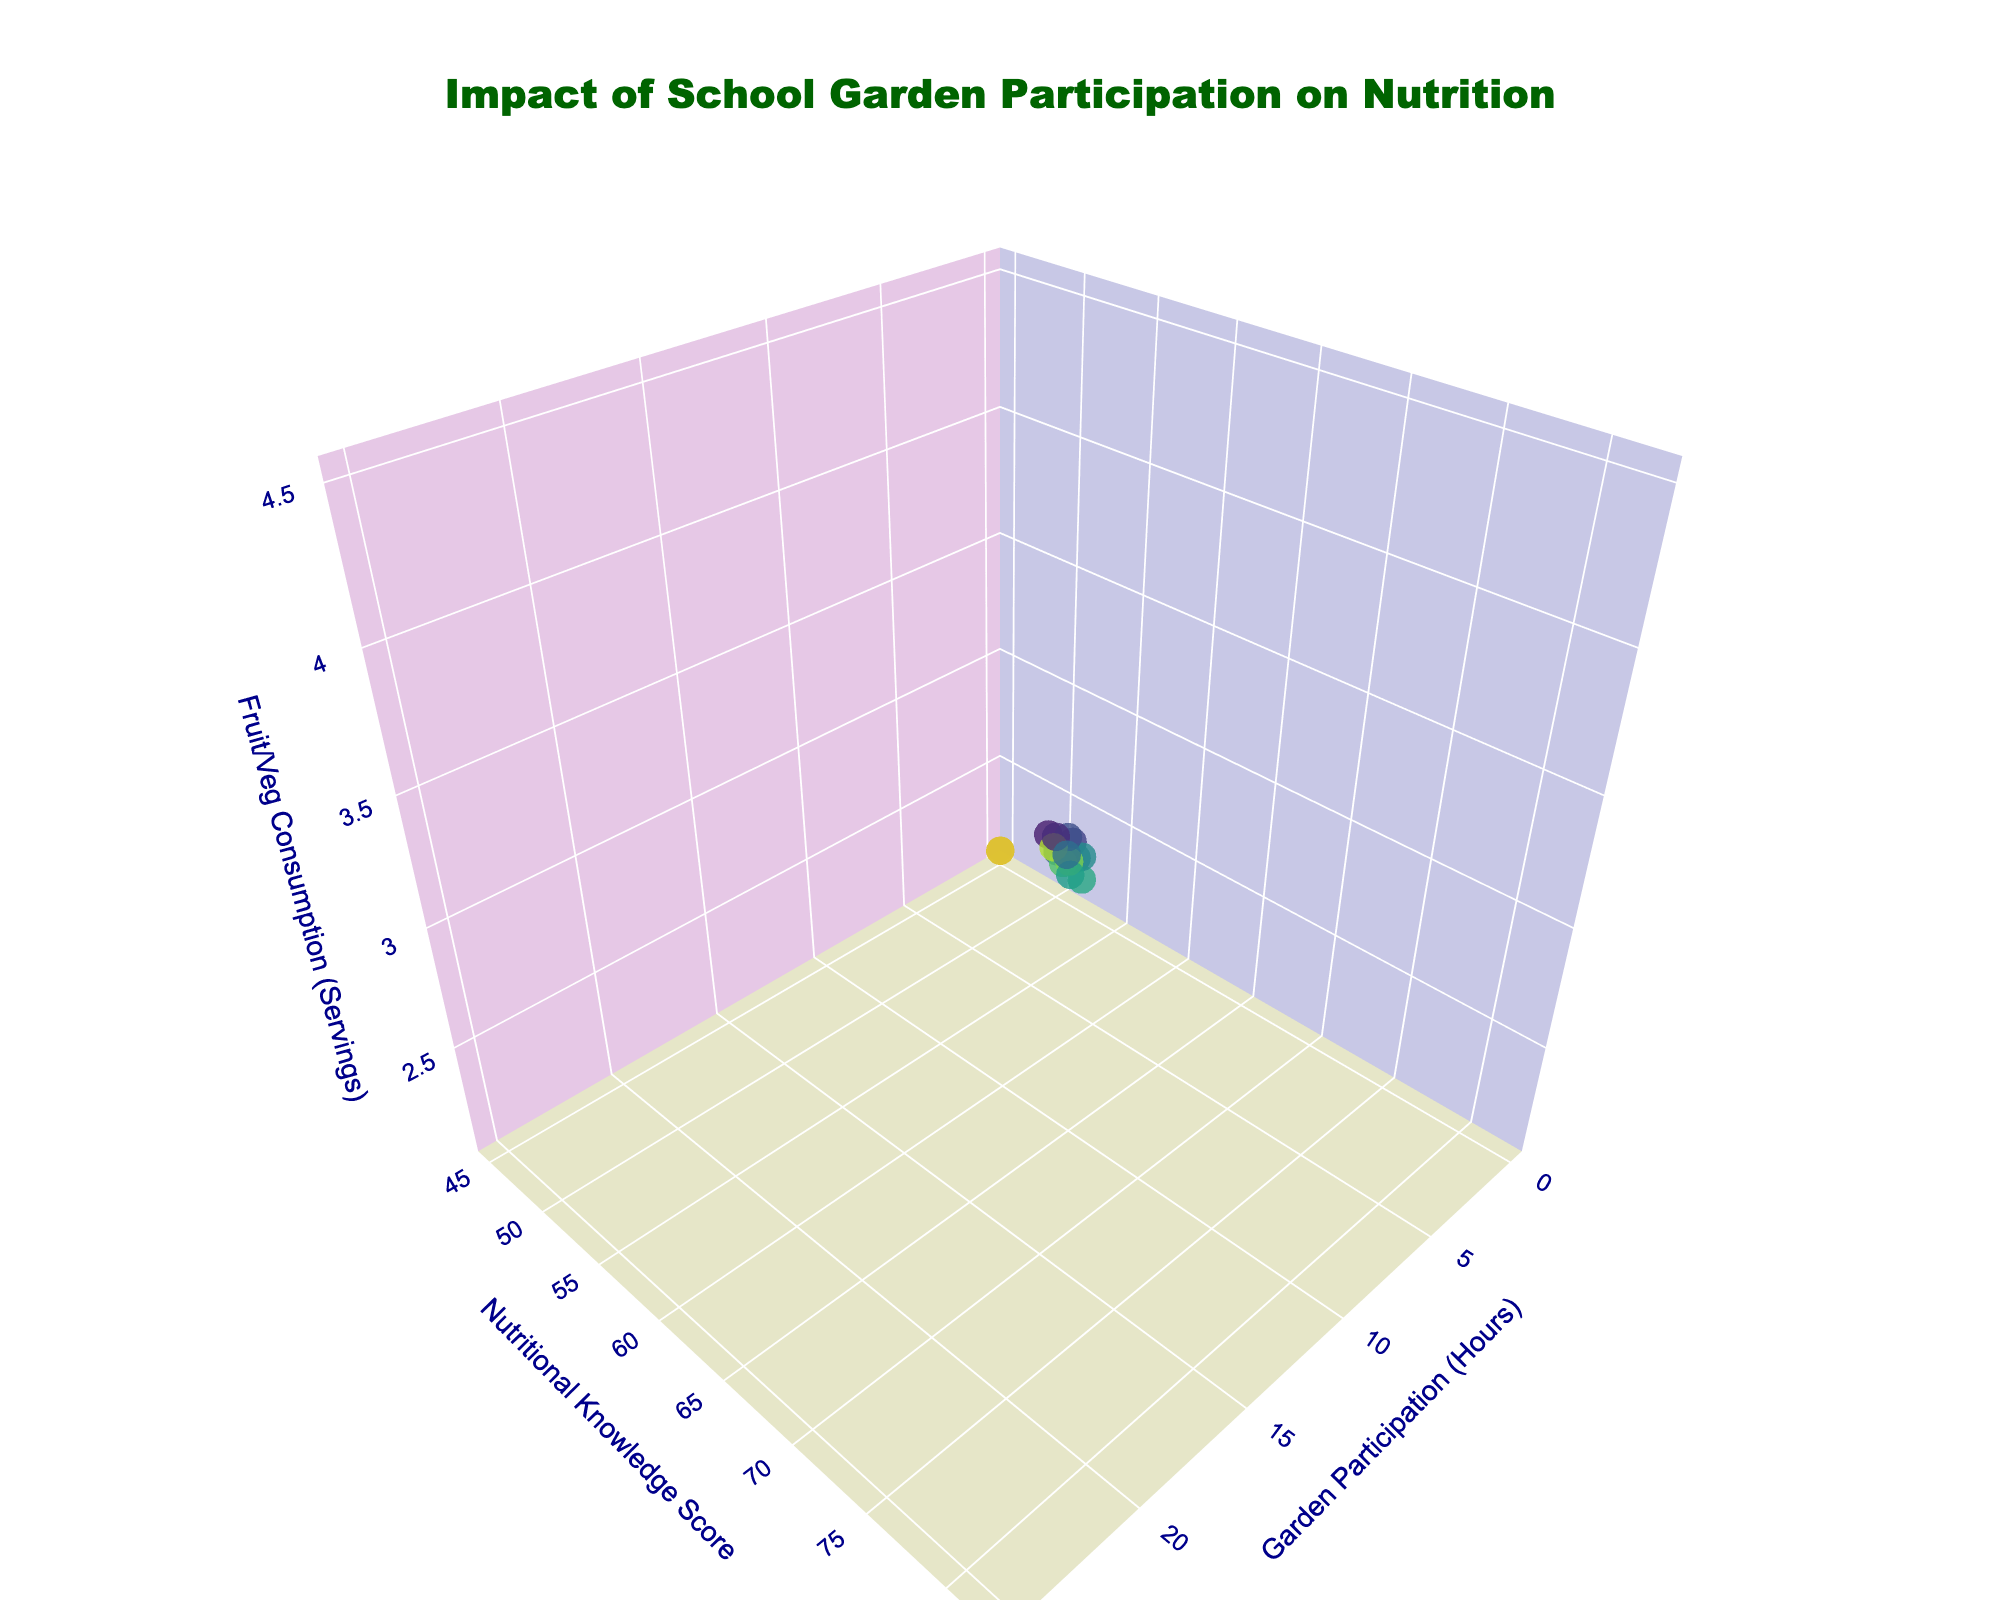How many schools are plotted on the graph? Count each data point in the plot, as each one represents a school. There are 15 schools plotted.
Answer: 15 What are the axes titles in the graph? There are three axes in the 3D plot, each with a title: "Garden Participation (Hours)" on the x-axis, "Nutritional Knowledge Score" on the y-axis, and "Fruit/Veg Consumption (Servings)" on the z-axis.
Answer: Garden Participation (Hours), Nutritional Knowledge Score, Fruit/Veg Consumption (Servings) Which school has the highest fruit and vegetable consumption? Look at the z-axis for the highest value point. The school with the highest value is Fairview Academy.
Answer: Fairview Academy Which school shows the lowest garden participation hours yet a high knowledge score? Check for the smallest x-axis value and then see if the y-axis value is high. Greenwood Elementary has 0 hours and a score of 45. For higher scores, Eastside Elementary has 3 hours and a score of 54.
Answer: Eastside Elementary On average, what is the nutritional knowledge score for schools with more than 10 garden participation hours? Identify schools with x > 10: Oak Ridge Academy, Lakeview Middle School, Hillside High, Brookside Charter, Central Middle School, Westfield High, Fairview Academy. Their scores are 65, 68, 75, 78, 70, 80, 82. Sum them and divide by the number: (65+68+75+78+70+80+82)/7 = 74
Answer: 74 Is there a positive correlation between garden participation hours and fruit/vegetable consumption? Observe the general trend of data points when moving in the positive direction along both axes. As Garden Participation Hours increase, Fruit/Veg Consumption also appears to increase, suggesting a positive correlation.
Answer: Yes Which school has a garden participation hour equal to 9? Look at the x-axis for the value 9 and see which school is at that point. Washington Middle School corresponds to garden participation of 9 hours.
Answer: Washington Middle School Compare the nutritional knowledge scores between Greenwood Elementary and Hillside High. Greenwood Elementary has a score of 45, and Hillside High has a score of 75. Hillside High has a higher score than Greenwood Elementary.
Answer: Hillside High What color scale is used to represent the garden participation hours? Observe the colors on the data points, which range from dark to light shades in a gradient. The Viridis color scale is used, moving from dark blue to yellow.
Answer: Viridis Which school has the lowest nutritional knowledge score with a significant number of garden participation hours? Look for the lowest y-axis value where the x-axis value is substantial. Sunset Middle School has a score of 52 with 2 hours, which is the lowest among schools with significant hours.
Answer: Sunset Middle School 